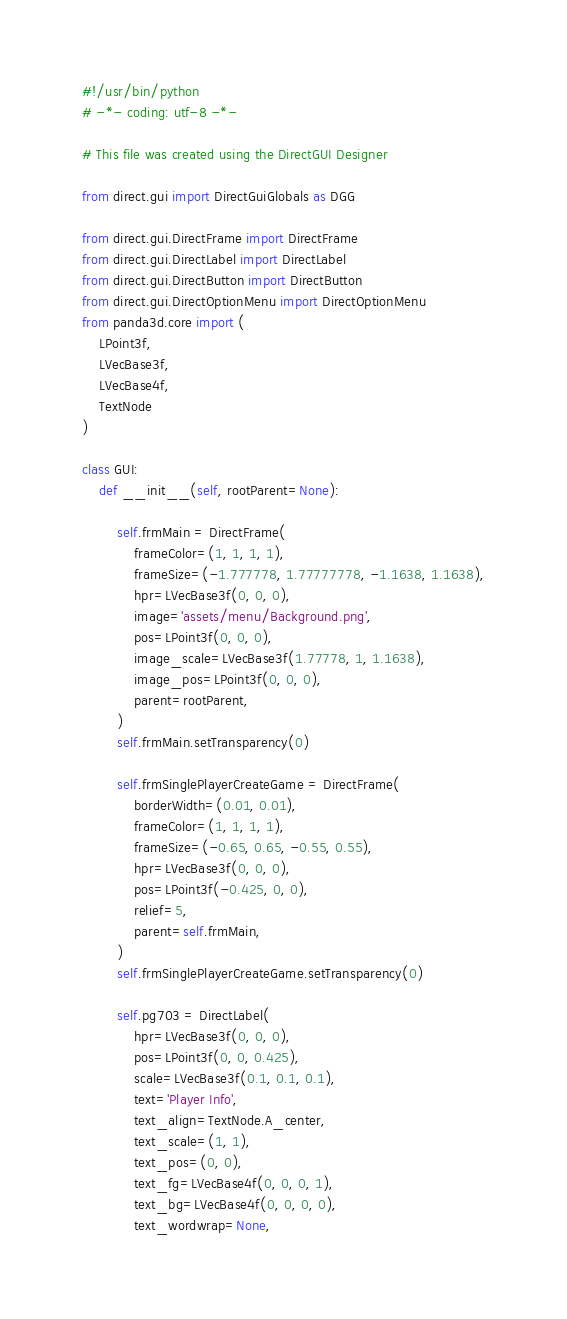Convert code to text. <code><loc_0><loc_0><loc_500><loc_500><_Python_>#!/usr/bin/python
# -*- coding: utf-8 -*-

# This file was created using the DirectGUI Designer

from direct.gui import DirectGuiGlobals as DGG

from direct.gui.DirectFrame import DirectFrame
from direct.gui.DirectLabel import DirectLabel
from direct.gui.DirectButton import DirectButton
from direct.gui.DirectOptionMenu import DirectOptionMenu
from panda3d.core import (
    LPoint3f,
    LVecBase3f,
    LVecBase4f,
    TextNode
)

class GUI:
    def __init__(self, rootParent=None):
        
        self.frmMain = DirectFrame(
            frameColor=(1, 1, 1, 1),
            frameSize=(-1.777778, 1.77777778, -1.1638, 1.1638),
            hpr=LVecBase3f(0, 0, 0),
            image='assets/menu/Background.png',
            pos=LPoint3f(0, 0, 0),
            image_scale=LVecBase3f(1.77778, 1, 1.1638),
            image_pos=LPoint3f(0, 0, 0),
            parent=rootParent,
        )
        self.frmMain.setTransparency(0)

        self.frmSinglePlayerCreateGame = DirectFrame(
            borderWidth=(0.01, 0.01),
            frameColor=(1, 1, 1, 1),
            frameSize=(-0.65, 0.65, -0.55, 0.55),
            hpr=LVecBase3f(0, 0, 0),
            pos=LPoint3f(-0.425, 0, 0),
            relief=5,
            parent=self.frmMain,
        )
        self.frmSinglePlayerCreateGame.setTransparency(0)

        self.pg703 = DirectLabel(
            hpr=LVecBase3f(0, 0, 0),
            pos=LPoint3f(0, 0, 0.425),
            scale=LVecBase3f(0.1, 0.1, 0.1),
            text='Player Info',
            text_align=TextNode.A_center,
            text_scale=(1, 1),
            text_pos=(0, 0),
            text_fg=LVecBase4f(0, 0, 0, 1),
            text_bg=LVecBase4f(0, 0, 0, 0),
            text_wordwrap=None,</code> 